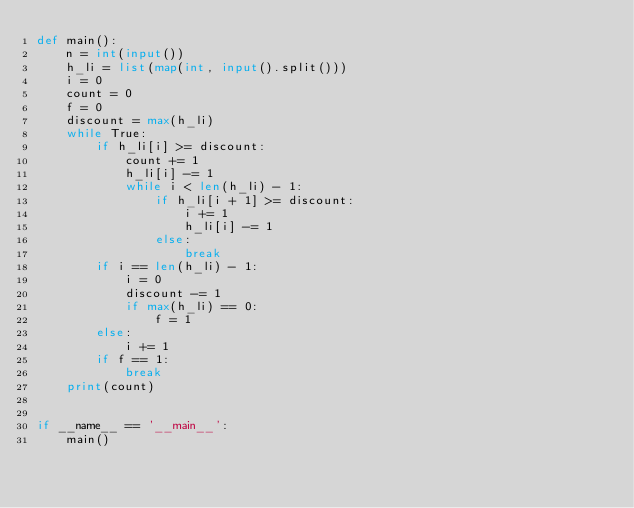Convert code to text. <code><loc_0><loc_0><loc_500><loc_500><_Python_>def main():
    n = int(input())
    h_li = list(map(int, input().split()))
    i = 0
    count = 0
    f = 0
    discount = max(h_li)
    while True:
        if h_li[i] >= discount:
            count += 1
            h_li[i] -= 1
            while i < len(h_li) - 1:
                if h_li[i + 1] >= discount:
                    i += 1
                    h_li[i] -= 1
                else:
                    break
        if i == len(h_li) - 1:
            i = 0
            discount -= 1
            if max(h_li) == 0:
                f = 1
        else:
            i += 1
        if f == 1:
            break
    print(count)


if __name__ == '__main__':
    main()
</code> 